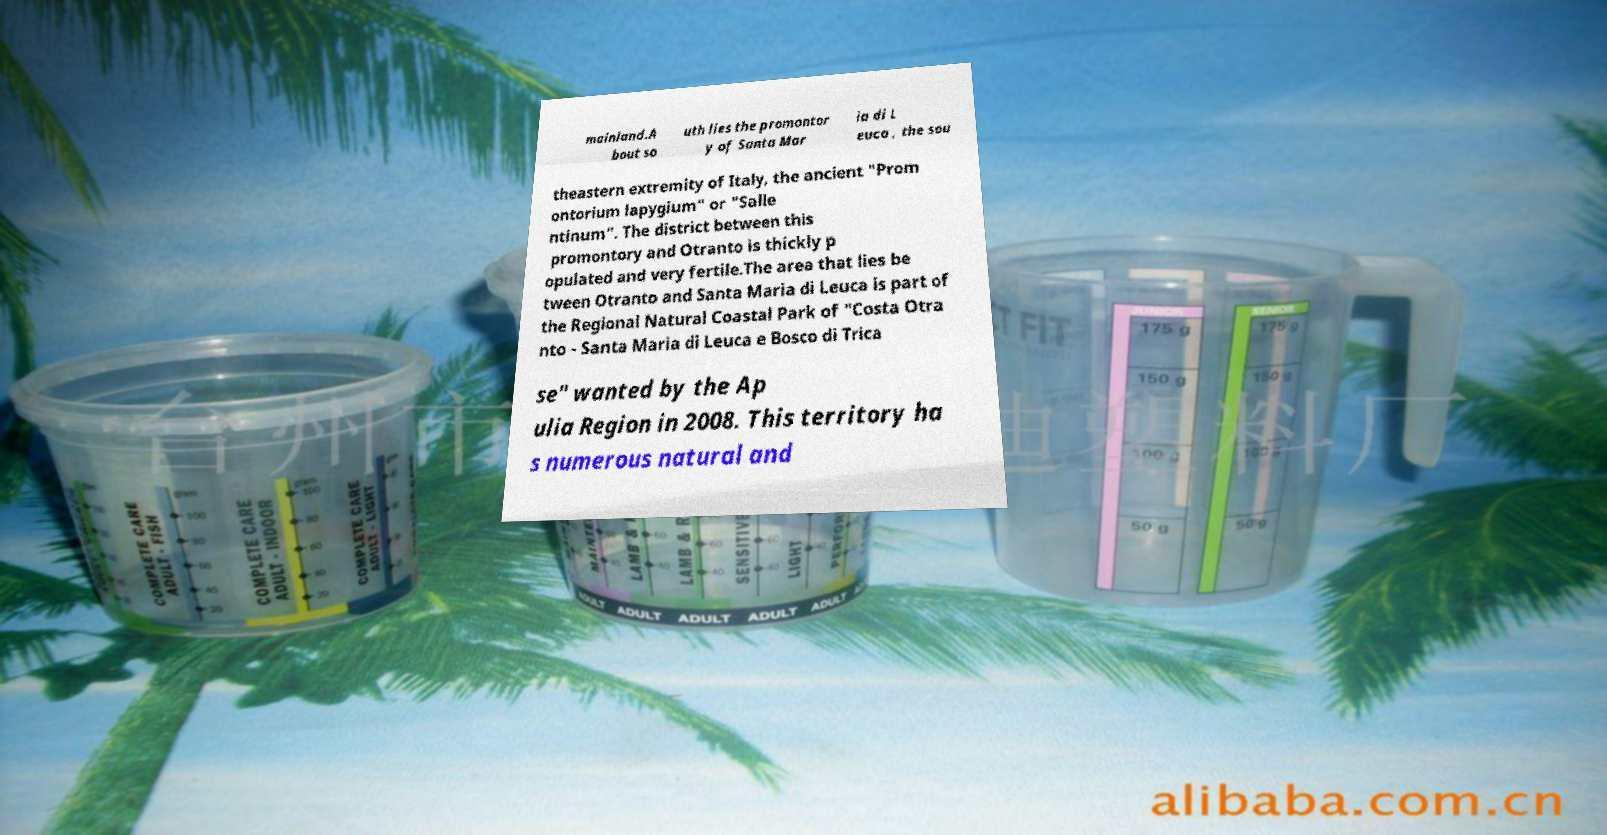What messages or text are displayed in this image? I need them in a readable, typed format. mainland.A bout so uth lies the promontor y of Santa Mar ia di L euca , the sou theastern extremity of Italy, the ancient "Prom ontorium lapygium" or "Salle ntinum". The district between this promontory and Otranto is thickly p opulated and very fertile.The area that lies be tween Otranto and Santa Maria di Leuca is part of the Regional Natural Coastal Park of "Costa Otra nto - Santa Maria di Leuca e Bosco di Trica se" wanted by the Ap ulia Region in 2008. This territory ha s numerous natural and 